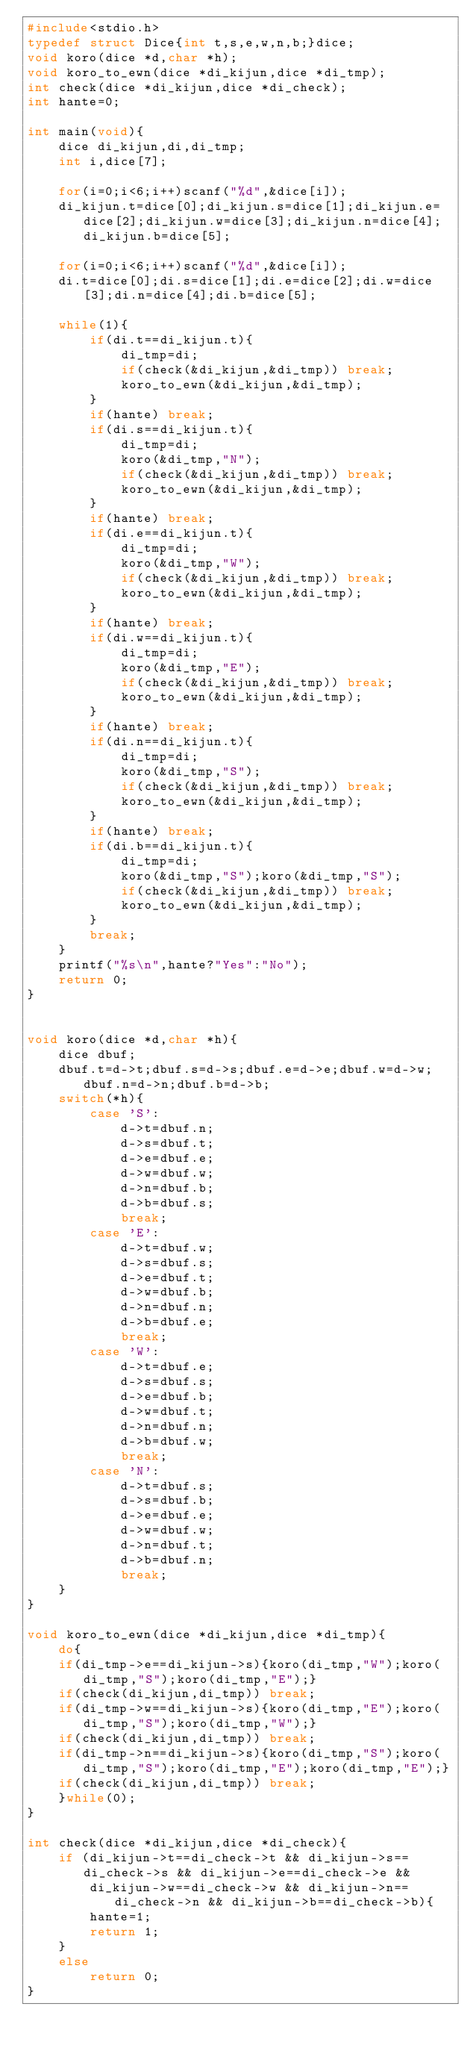<code> <loc_0><loc_0><loc_500><loc_500><_C_>#include<stdio.h>
typedef struct Dice{int t,s,e,w,n,b;}dice;
void koro(dice *d,char *h);
void koro_to_ewn(dice *di_kijun,dice *di_tmp);
int check(dice *di_kijun,dice *di_check);
int hante=0;

int main(void){
    dice di_kijun,di,di_tmp;
    int i,dice[7];

    for(i=0;i<6;i++)scanf("%d",&dice[i]);
    di_kijun.t=dice[0];di_kijun.s=dice[1];di_kijun.e=dice[2];di_kijun.w=dice[3];di_kijun.n=dice[4];di_kijun.b=dice[5];
	
	for(i=0;i<6;i++)scanf("%d",&dice[i]);
    di.t=dice[0];di.s=dice[1];di.e=dice[2];di.w=dice[3];di.n=dice[4];di.b=dice[5];

	while(1){
		if(di.t==di_kijun.t){
			di_tmp=di;
			if(check(&di_kijun,&di_tmp)) break;
			koro_to_ewn(&di_kijun,&di_tmp);
		}
		if(hante) break;
		if(di.s==di_kijun.t){
			di_tmp=di;
			koro(&di_tmp,"N");
			if(check(&di_kijun,&di_tmp)) break;
			koro_to_ewn(&di_kijun,&di_tmp);
		}
		if(hante) break;
		if(di.e==di_kijun.t){
			di_tmp=di;
			koro(&di_tmp,"W");
			if(check(&di_kijun,&di_tmp)) break;
			koro_to_ewn(&di_kijun,&di_tmp);
		}
		if(hante) break;
		if(di.w==di_kijun.t){
			di_tmp=di;
			koro(&di_tmp,"E");
			if(check(&di_kijun,&di_tmp)) break;
			koro_to_ewn(&di_kijun,&di_tmp);
		}
		if(hante) break;
		if(di.n==di_kijun.t){
			di_tmp=di;
			koro(&di_tmp,"S");
			if(check(&di_kijun,&di_tmp)) break;
			koro_to_ewn(&di_kijun,&di_tmp);
		}
		if(hante) break;
		if(di.b==di_kijun.t){
			di_tmp=di;
			koro(&di_tmp,"S");koro(&di_tmp,"S");
			if(check(&di_kijun,&di_tmp)) break;
			koro_to_ewn(&di_kijun,&di_tmp);
		}
		break;
	}
	printf("%s\n",hante?"Yes":"No");
    return 0;
}


void koro(dice *d,char *h){
    dice dbuf;
    dbuf.t=d->t;dbuf.s=d->s;dbuf.e=d->e;dbuf.w=d->w;dbuf.n=d->n;dbuf.b=d->b;
    switch(*h){
        case 'S':
            d->t=dbuf.n;
            d->s=dbuf.t;
            d->e=dbuf.e;
            d->w=dbuf.w;
            d->n=dbuf.b;
            d->b=dbuf.s;
            break;
        case 'E':
            d->t=dbuf.w;
            d->s=dbuf.s;
            d->e=dbuf.t;
            d->w=dbuf.b;
            d->n=dbuf.n;
            d->b=dbuf.e;
            break;
        case 'W':
            d->t=dbuf.e;
            d->s=dbuf.s;
            d->e=dbuf.b;
            d->w=dbuf.t;
            d->n=dbuf.n;
            d->b=dbuf.w;
            break;
        case 'N':
            d->t=dbuf.s;
            d->s=dbuf.b;
            d->e=dbuf.e;
            d->w=dbuf.w;
            d->n=dbuf.t;
            d->b=dbuf.n;
            break;
    }
}

void koro_to_ewn(dice *di_kijun,dice *di_tmp){
	do{
	if(di_tmp->e==di_kijun->s){koro(di_tmp,"W");koro(di_tmp,"S");koro(di_tmp,"E");}
	if(check(di_kijun,di_tmp)) break;
	if(di_tmp->w==di_kijun->s){koro(di_tmp,"E");koro(di_tmp,"S");koro(di_tmp,"W");}		
	if(check(di_kijun,di_tmp)) break;
	if(di_tmp->n==di_kijun->s){koro(di_tmp,"S");koro(di_tmp,"S");koro(di_tmp,"E");koro(di_tmp,"E");} 
	if(check(di_kijun,di_tmp)) break;
	}while(0);
}

int check(dice *di_kijun,dice *di_check){
	if (di_kijun->t==di_check->t && di_kijun->s==di_check->s && di_kijun->e==di_check->e &&
		di_kijun->w==di_check->w && di_kijun->n==di_check->n && di_kijun->b==di_check->b){
		hante=1;
		return 1;
	}
	else
		return 0;
}</code> 